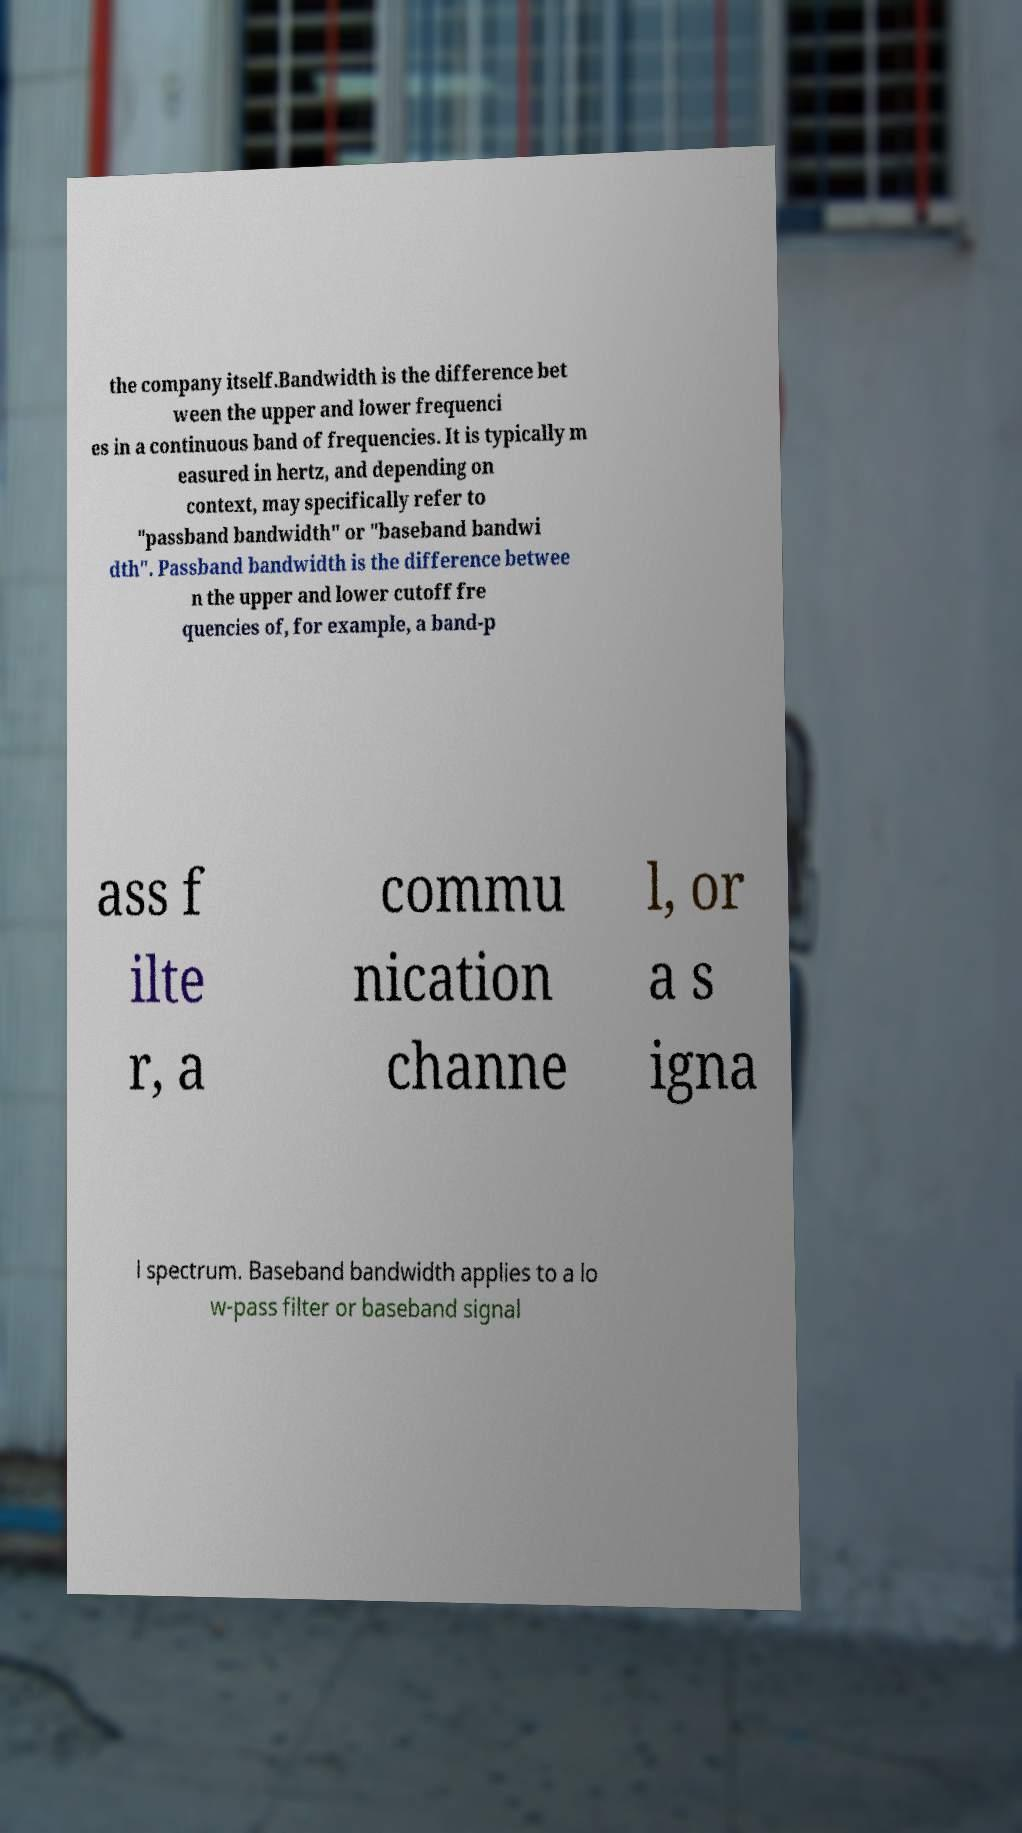What messages or text are displayed in this image? I need them in a readable, typed format. the company itself.Bandwidth is the difference bet ween the upper and lower frequenci es in a continuous band of frequencies. It is typically m easured in hertz, and depending on context, may specifically refer to "passband bandwidth" or "baseband bandwi dth". Passband bandwidth is the difference betwee n the upper and lower cutoff fre quencies of, for example, a band-p ass f ilte r, a commu nication channe l, or a s igna l spectrum. Baseband bandwidth applies to a lo w-pass filter or baseband signal 